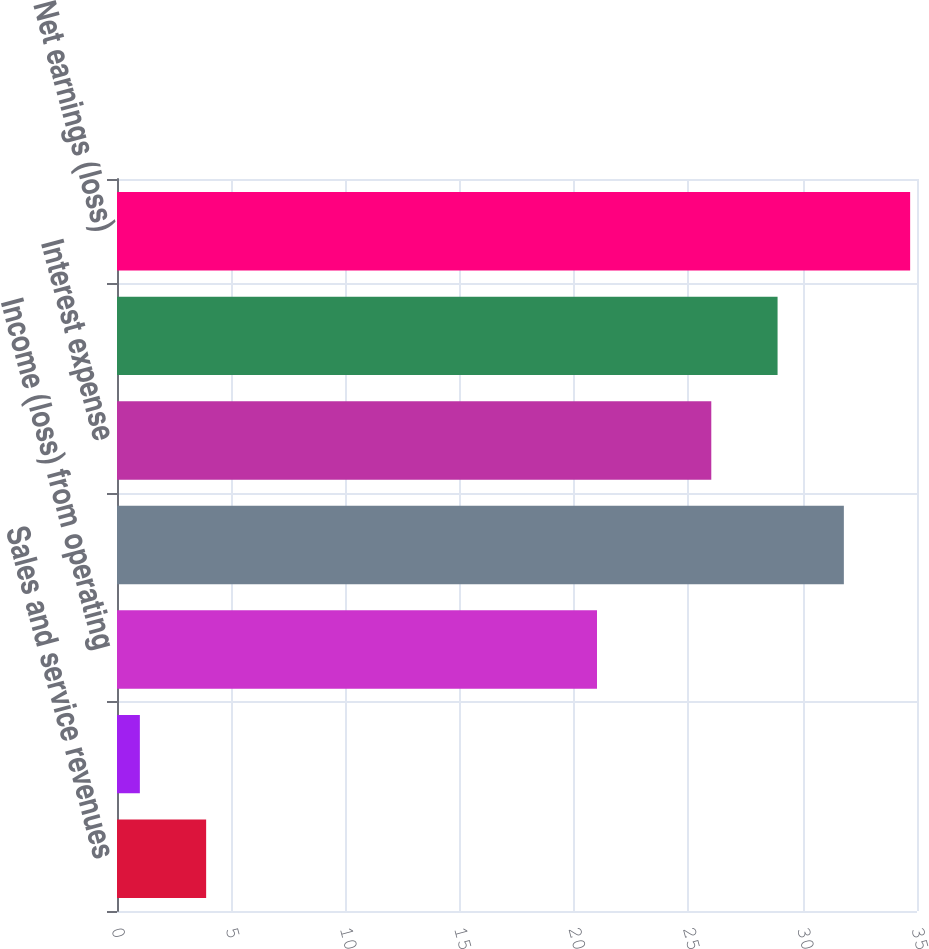Convert chart. <chart><loc_0><loc_0><loc_500><loc_500><bar_chart><fcel>Sales and service revenues<fcel>Cost of product sales and<fcel>Income (loss) from operating<fcel>Operating income (loss)<fcel>Interest expense<fcel>Federal and foreign income<fcel>Net earnings (loss)<nl><fcel>3.9<fcel>1<fcel>21<fcel>31.8<fcel>26<fcel>28.9<fcel>34.7<nl></chart> 